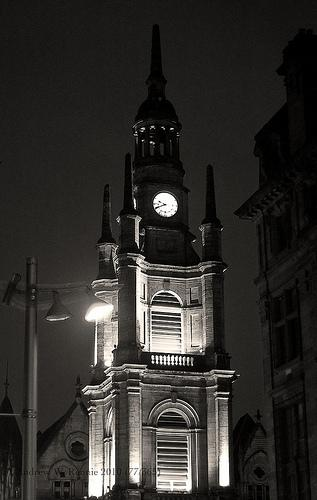Question: how many animals are in the photo?
Choices:
A. One.
B. None.
C. Two.
D. Three.
Answer with the letter. Answer: B Question: what time does the clock show?
Choices:
A. 9:40.
B. 11:12.
C. Noon.
D. 6 pm.
Answer with the letter. Answer: A Question: how many people are shown?
Choices:
A. None.
B. Many.
C. One.
D. Five.
Answer with the letter. Answer: A Question: what shape is the clock?
Choices:
A. Square.
B. Triangle.
C. Rectangle.
D. Round.
Answer with the letter. Answer: D Question: when was this photo taken?
Choices:
A. Sunset.
B. Sunrise.
C. Nighttime.
D. Daytime.
Answer with the letter. Answer: C 